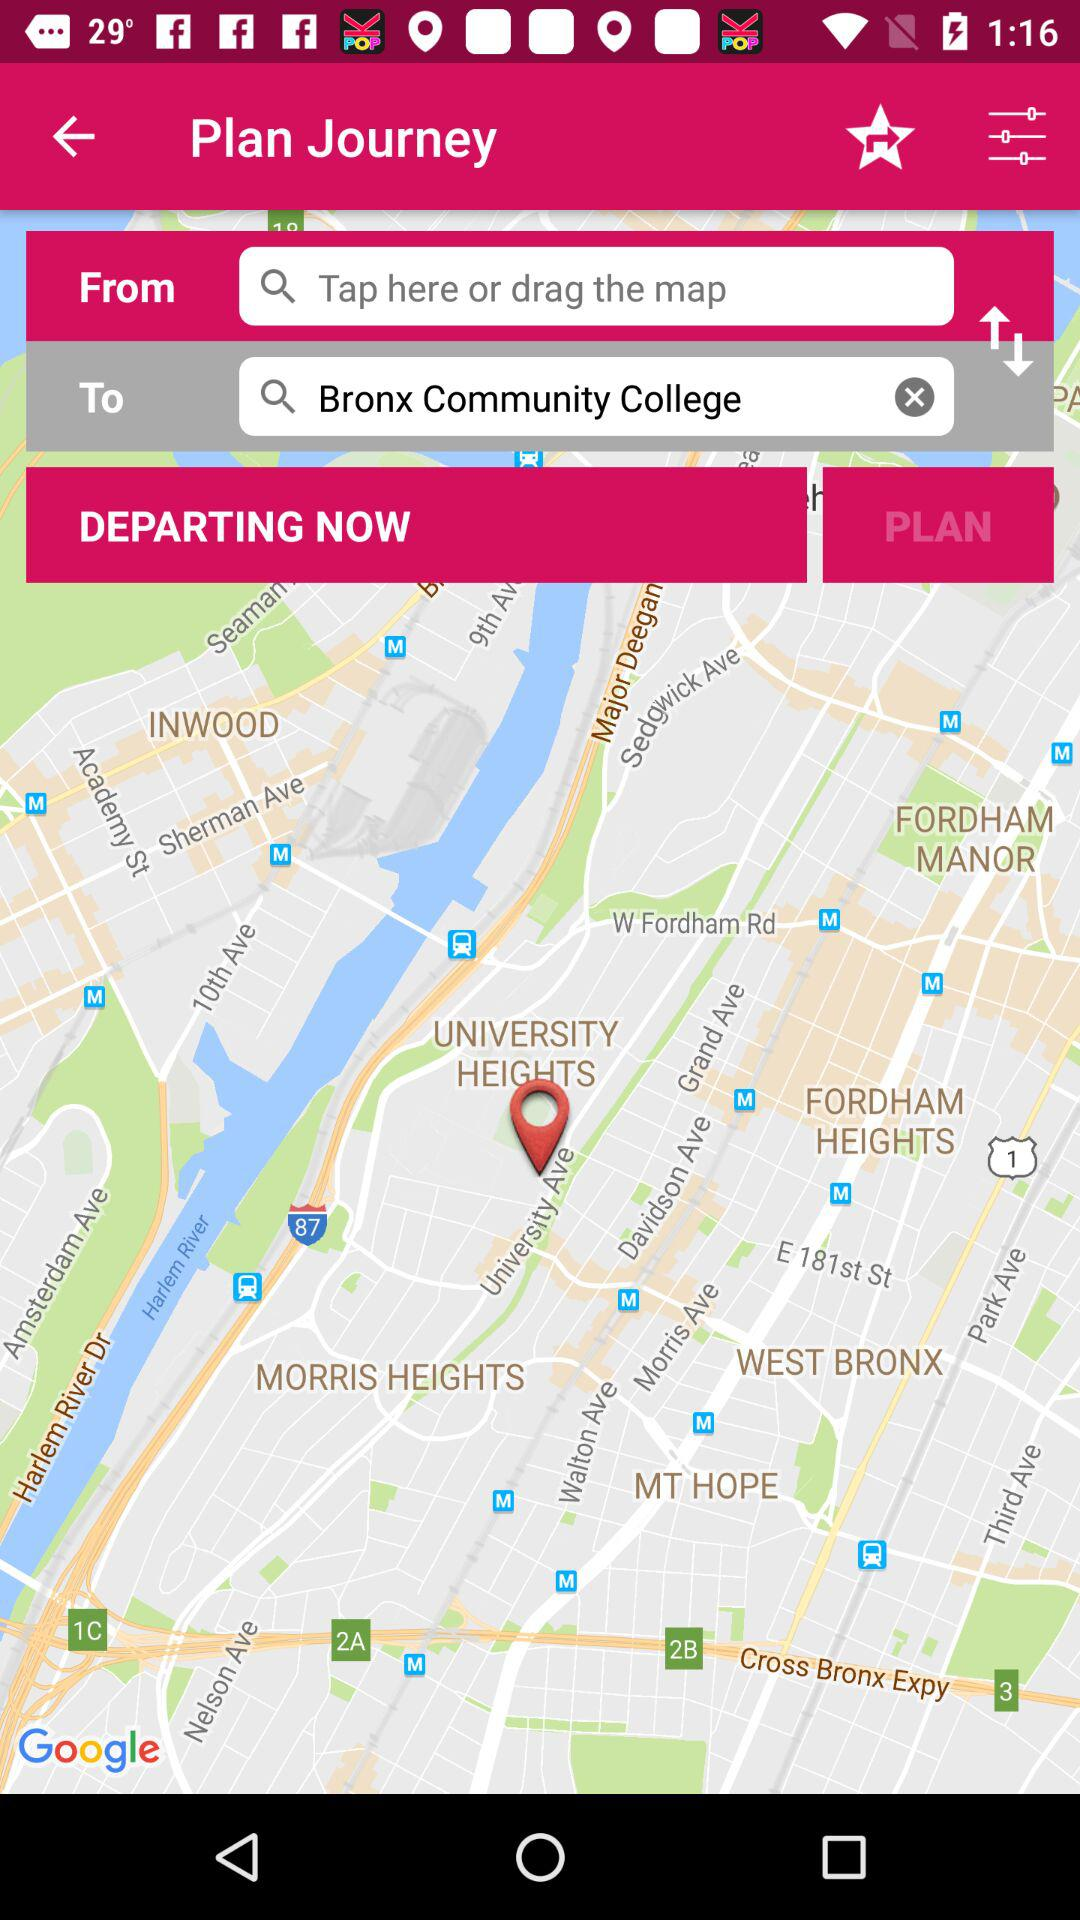Where does the journey depart from?
When the provided information is insufficient, respond with <no answer>. <no answer> 